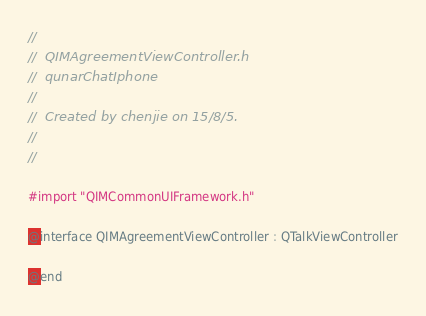<code> <loc_0><loc_0><loc_500><loc_500><_C_>//
//  QIMAgreementViewController.h
//  qunarChatIphone
//
//  Created by chenjie on 15/8/5.
//
//

#import "QIMCommonUIFramework.h"

@interface QIMAgreementViewController : QTalkViewController

@end
</code> 